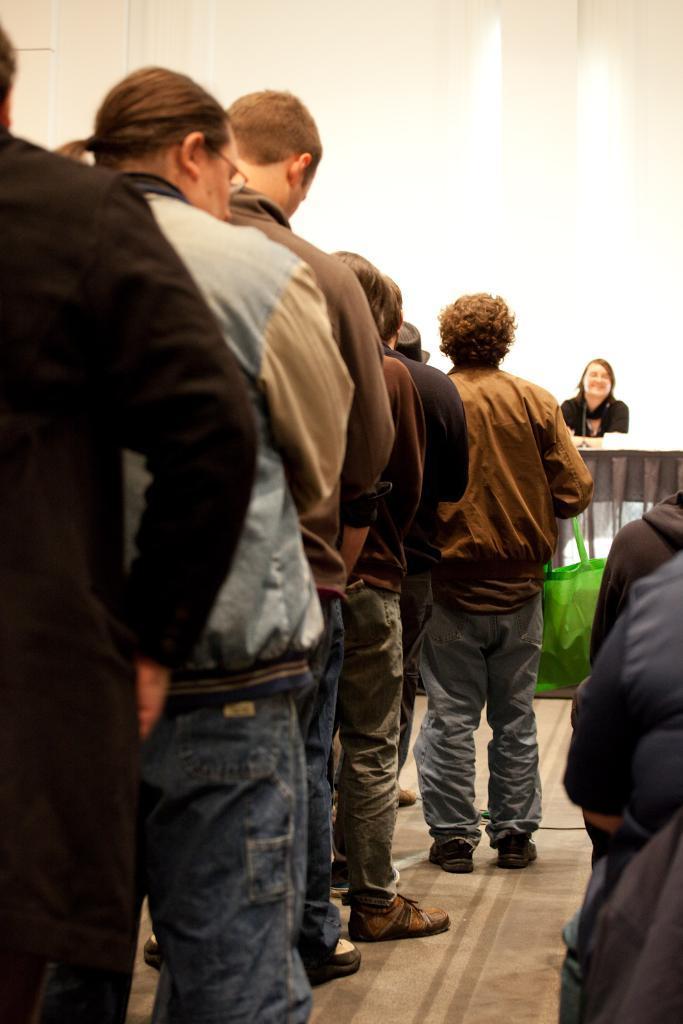Describe this image in one or two sentences. I can see few people standing in a line. This looks like a green color bag. Here is the woman sitting. The background looks white in color. At the right corner of the image, I can see two people. 